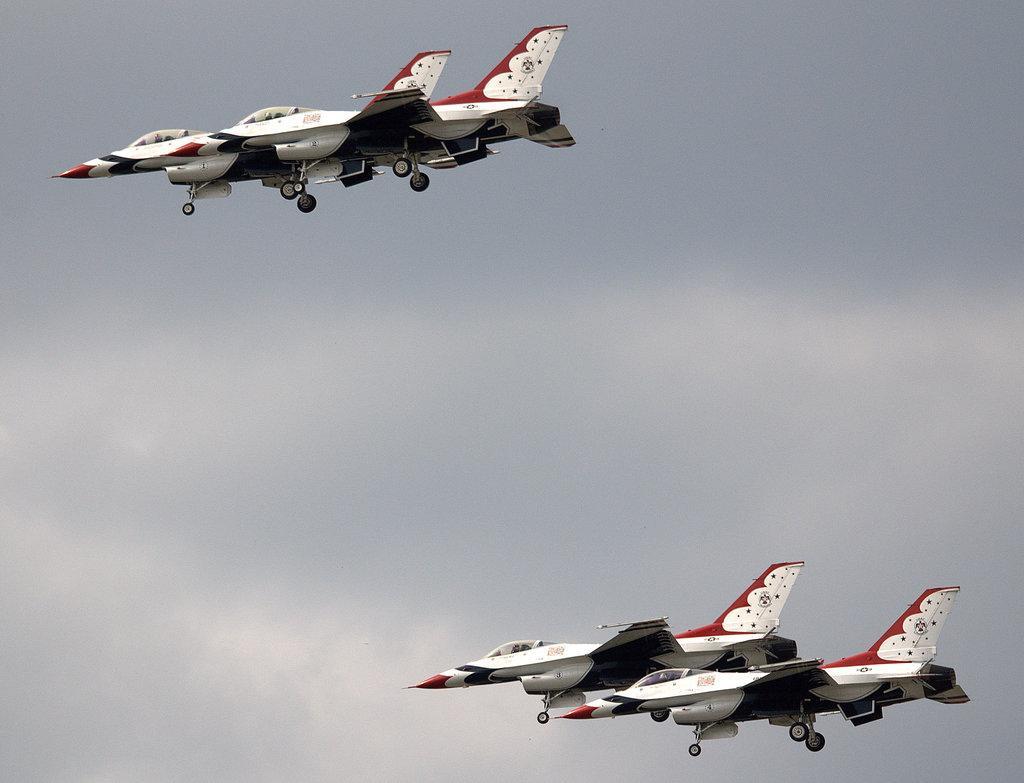Please provide a concise description of this image. Aeroplanes are flying in the sky towards the left. 